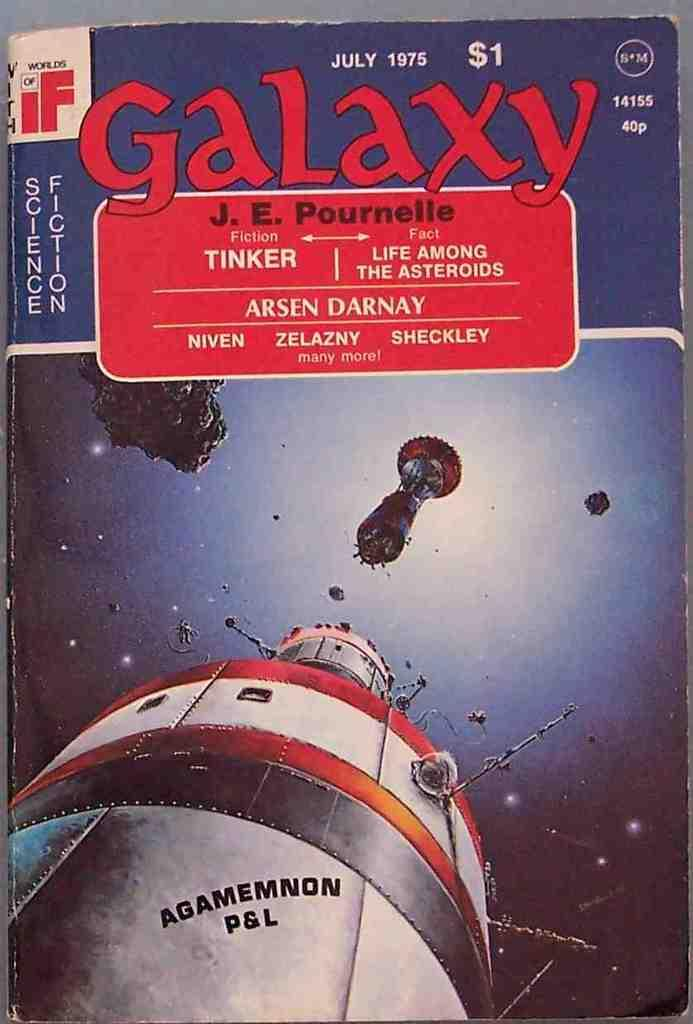<image>
Write a terse but informative summary of the picture. The july 1975 cover of Galaxy features the spaceship Agamemnon P&L 